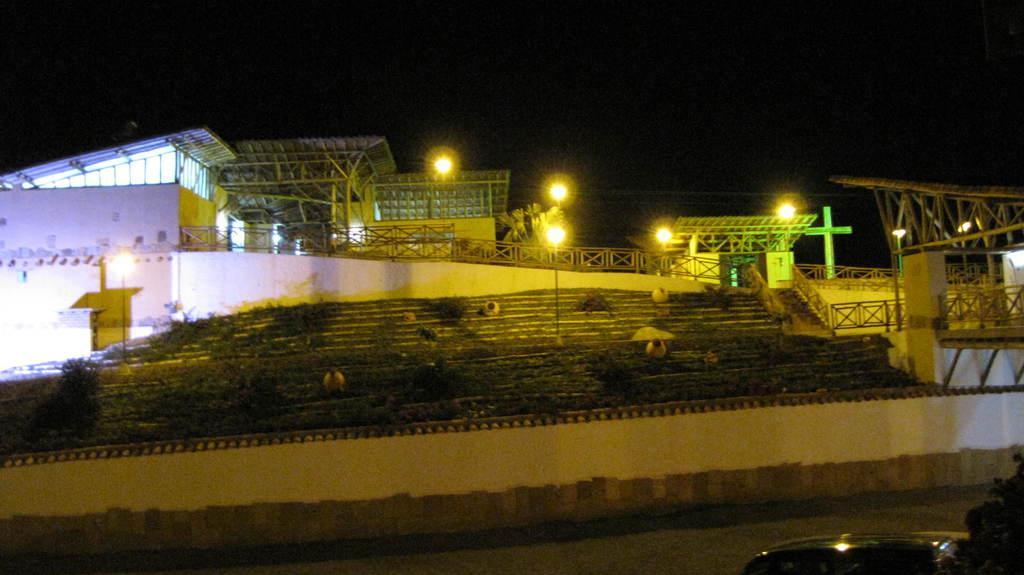How would you summarize this image in a sentence or two? At the bottom of the picture, we see a white wall and behind that, there are pots in the garden. Beside that, we see the staircase. Behind that, we see wooden fence and iron railing. There is a white building. We even see street lights and in the background, it is black in color. This picture is clicked in the dark. 